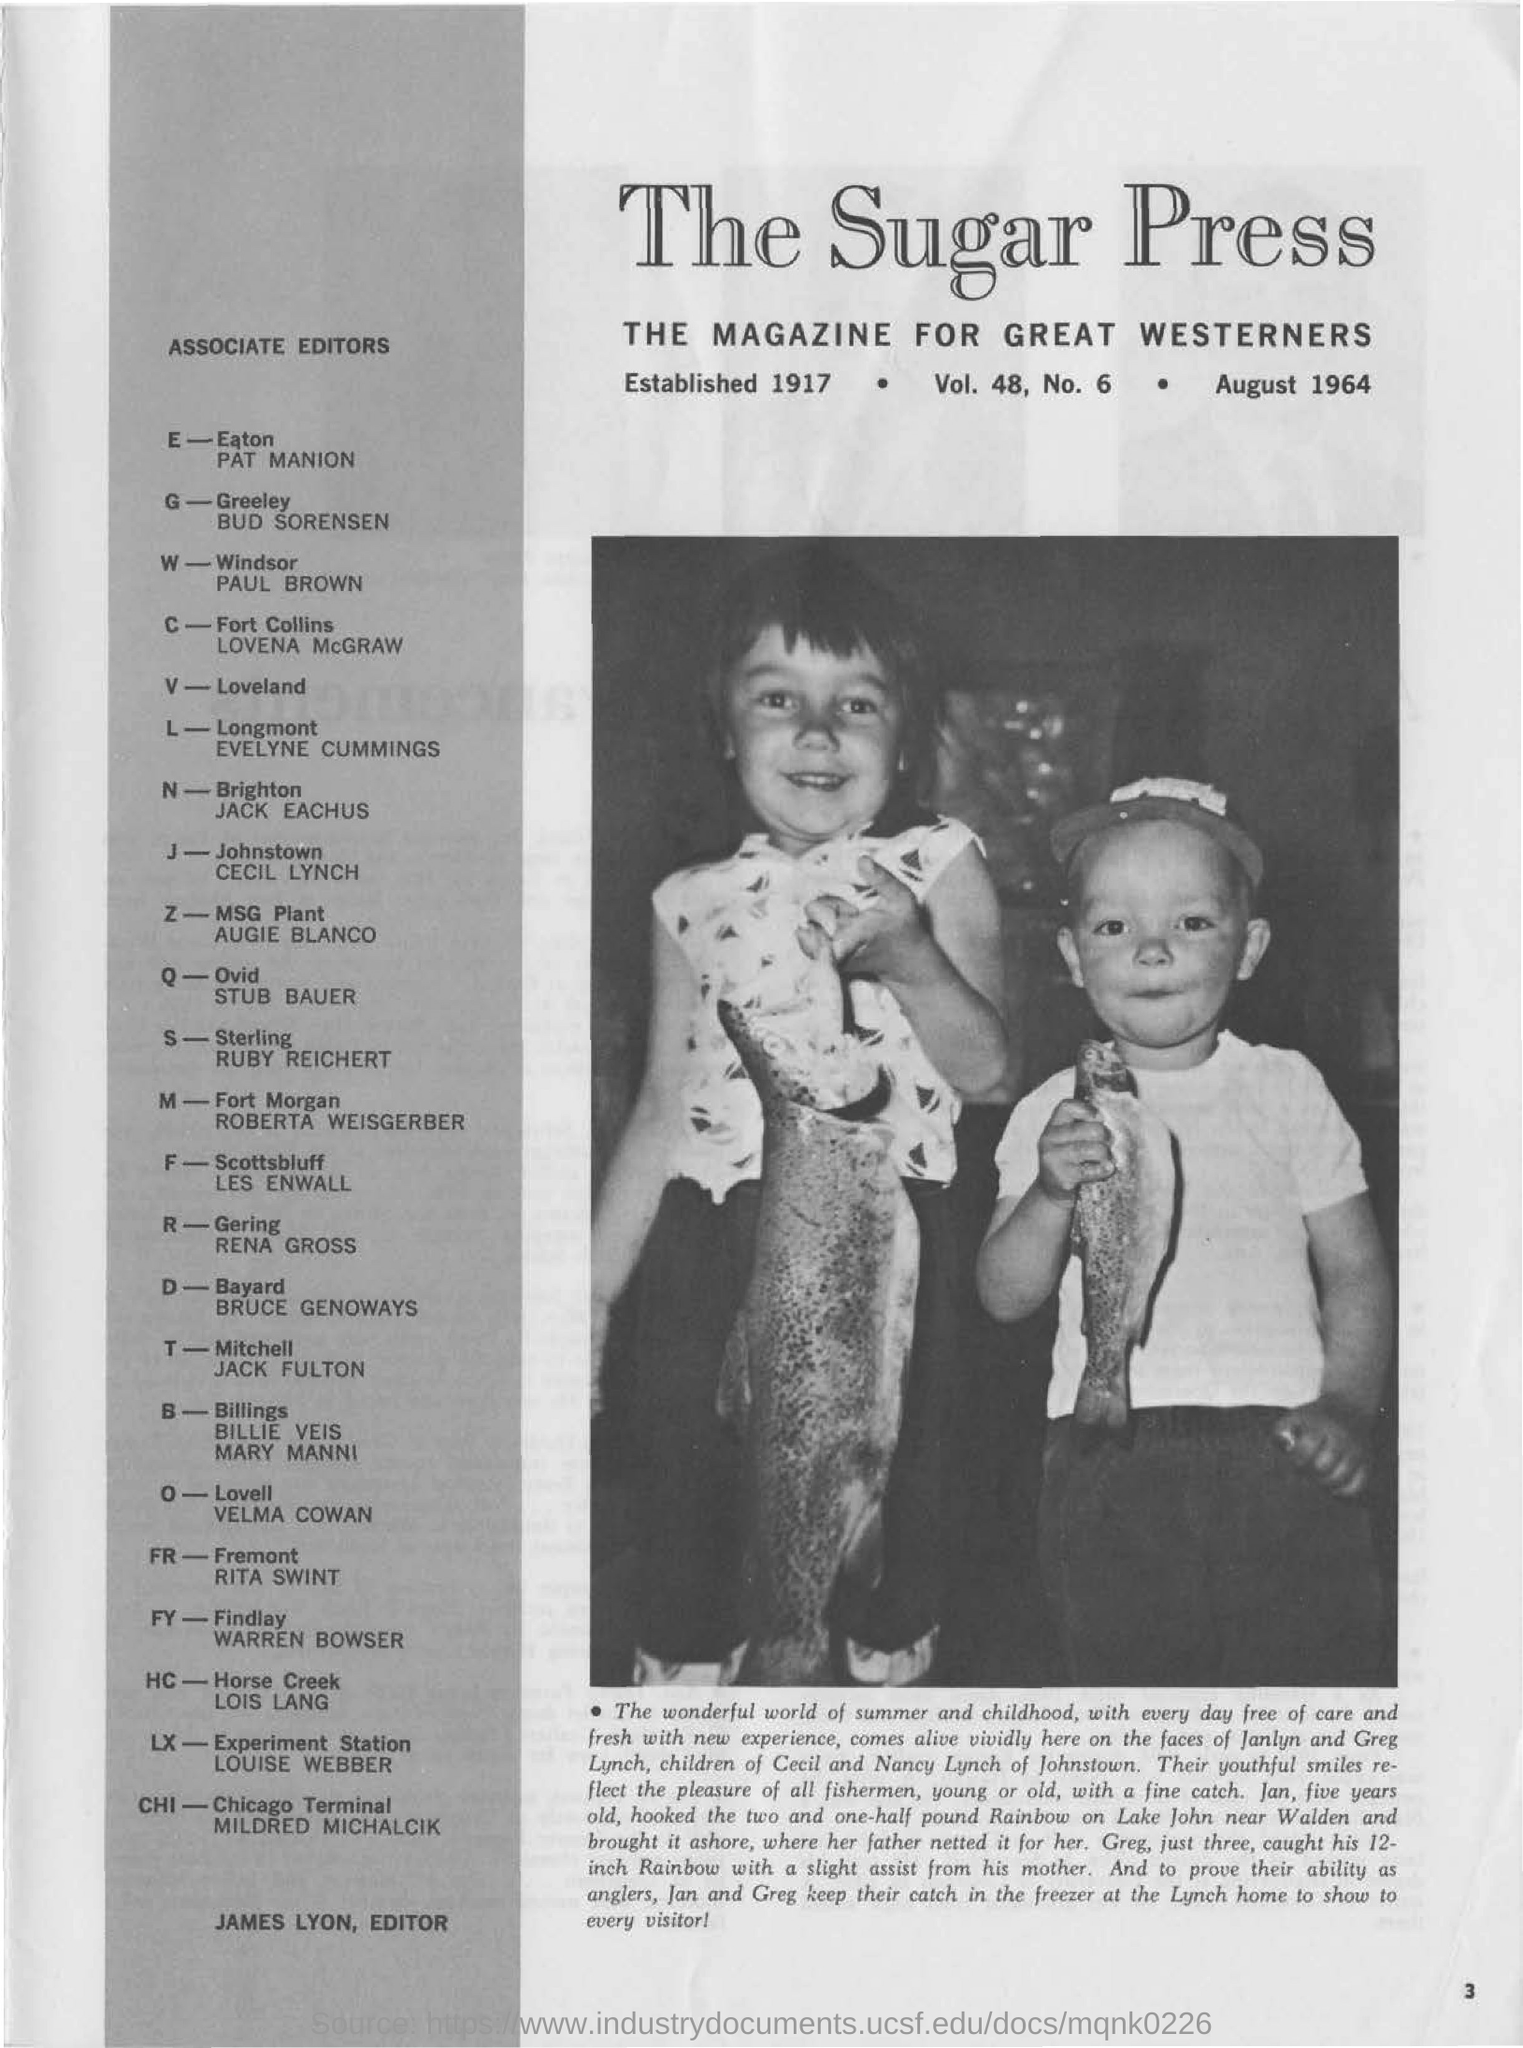Specify some key components in this picture. The bold heading reads "The Sugar Press. This magazine is intended for great Westerners. Greg's age is three. Jack Eachus is the associate editor for Brighton. 